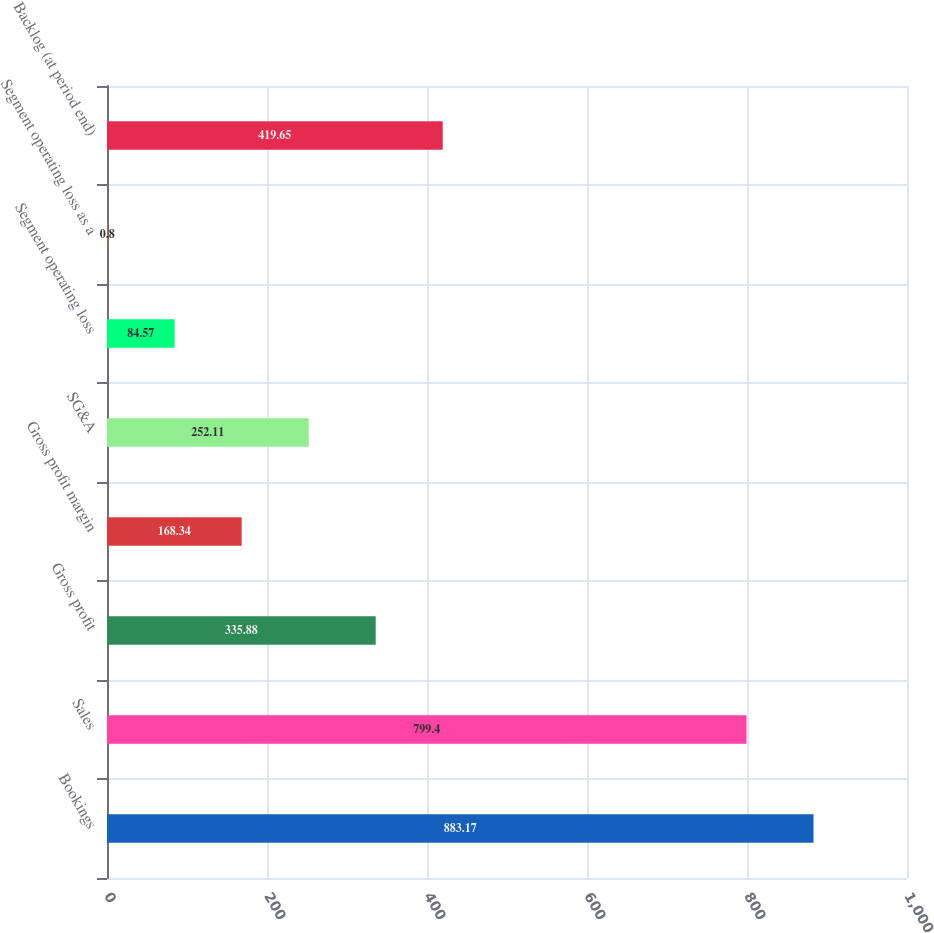Convert chart to OTSL. <chart><loc_0><loc_0><loc_500><loc_500><bar_chart><fcel>Bookings<fcel>Sales<fcel>Gross profit<fcel>Gross profit margin<fcel>SG&A<fcel>Segment operating loss<fcel>Segment operating loss as a<fcel>Backlog (at period end)<nl><fcel>883.17<fcel>799.4<fcel>335.88<fcel>168.34<fcel>252.11<fcel>84.57<fcel>0.8<fcel>419.65<nl></chart> 